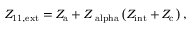<formula> <loc_0><loc_0><loc_500><loc_500>Z _ { 1 1 , e x t } = Z _ { a } + Z _ { \ a l p h a } \left ( Z _ { i n t } + Z _ { c } \right ) ,</formula> 